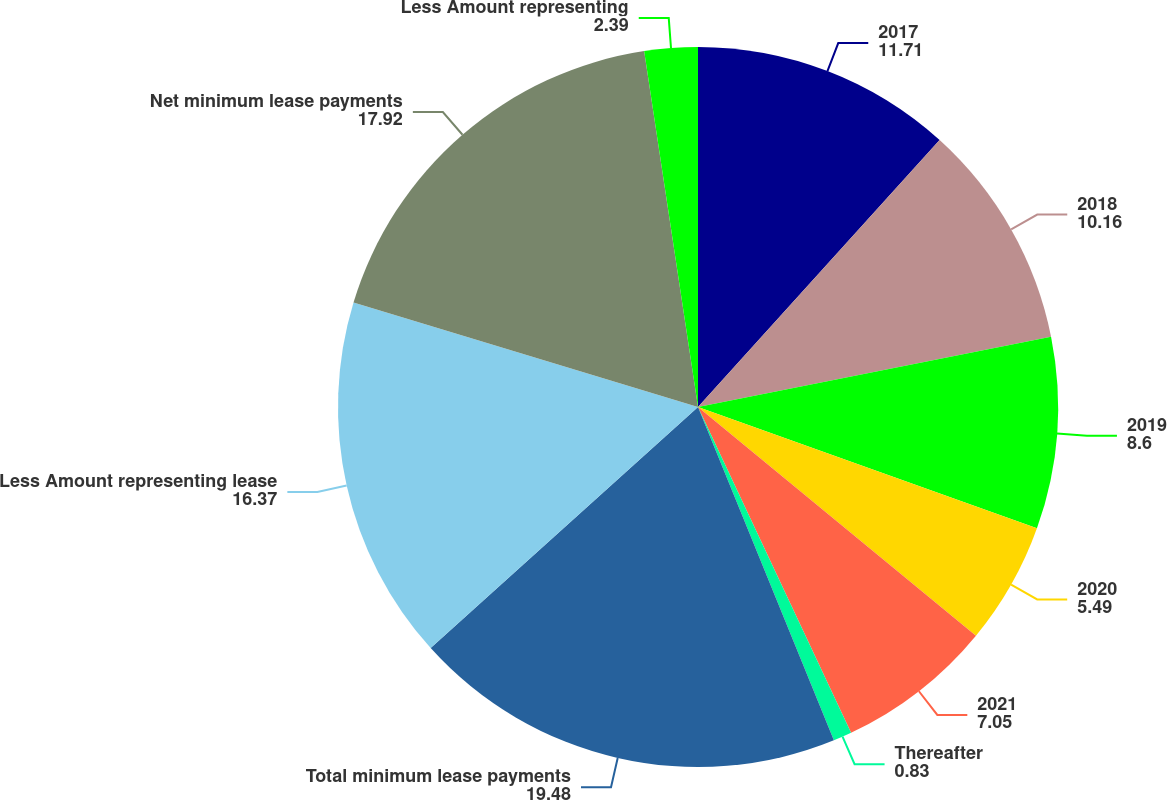Convert chart to OTSL. <chart><loc_0><loc_0><loc_500><loc_500><pie_chart><fcel>2017<fcel>2018<fcel>2019<fcel>2020<fcel>2021<fcel>Thereafter<fcel>Total minimum lease payments<fcel>Less Amount representing lease<fcel>Net minimum lease payments<fcel>Less Amount representing<nl><fcel>11.71%<fcel>10.16%<fcel>8.6%<fcel>5.49%<fcel>7.05%<fcel>0.83%<fcel>19.48%<fcel>16.37%<fcel>17.92%<fcel>2.39%<nl></chart> 